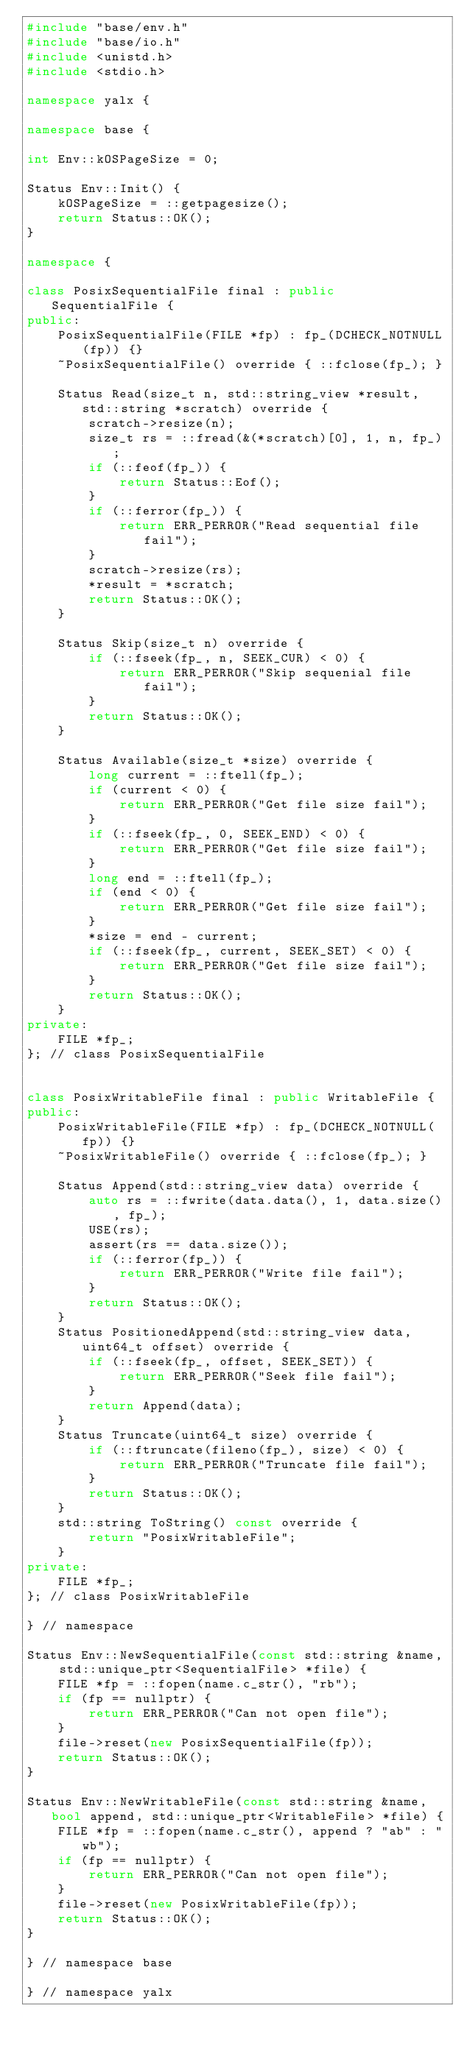Convert code to text. <code><loc_0><loc_0><loc_500><loc_500><_C++_>#include "base/env.h"
#include "base/io.h"
#include <unistd.h>
#include <stdio.h>

namespace yalx {

namespace base {

int Env::kOSPageSize = 0;

Status Env::Init() {
    kOSPageSize = ::getpagesize();
    return Status::OK();
}

namespace {

class PosixSequentialFile final : public SequentialFile {
public:
    PosixSequentialFile(FILE *fp) : fp_(DCHECK_NOTNULL(fp)) {}
    ~PosixSequentialFile() override { ::fclose(fp_); }
    
    Status Read(size_t n, std::string_view *result, std::string *scratch) override {
        scratch->resize(n);
        size_t rs = ::fread(&(*scratch)[0], 1, n, fp_);
        if (::feof(fp_)) {
            return Status::Eof();
        }
        if (::ferror(fp_)) {
            return ERR_PERROR("Read sequential file fail");
        }
        scratch->resize(rs);
        *result = *scratch;
        return Status::OK();
    }

    Status Skip(size_t n) override {
        if (::fseek(fp_, n, SEEK_CUR) < 0) {
            return ERR_PERROR("Skip sequenial file fail");
        }
        return Status::OK();
    }

    Status Available(size_t *size) override {
        long current = ::ftell(fp_);
        if (current < 0) {
            return ERR_PERROR("Get file size fail");
        }
        if (::fseek(fp_, 0, SEEK_END) < 0) {
            return ERR_PERROR("Get file size fail");
        }
        long end = ::ftell(fp_);
        if (end < 0) {
            return ERR_PERROR("Get file size fail");
        }
        *size = end - current;
        if (::fseek(fp_, current, SEEK_SET) < 0) {
            return ERR_PERROR("Get file size fail");
        }
        return Status::OK();
    }
private:
    FILE *fp_;
}; // class PosixSequentialFile


class PosixWritableFile final : public WritableFile {
public:
    PosixWritableFile(FILE *fp) : fp_(DCHECK_NOTNULL(fp)) {}
    ~PosixWritableFile() override { ::fclose(fp_); }
    
    Status Append(std::string_view data) override {
        auto rs = ::fwrite(data.data(), 1, data.size(), fp_);
        USE(rs);
        assert(rs == data.size());
        if (::ferror(fp_)) {
            return ERR_PERROR("Write file fail");
        }
        return Status::OK();
    }
    Status PositionedAppend(std::string_view data, uint64_t offset) override {
        if (::fseek(fp_, offset, SEEK_SET)) {
            return ERR_PERROR("Seek file fail");
        }
        return Append(data);
    }
    Status Truncate(uint64_t size) override {
        if (::ftruncate(fileno(fp_), size) < 0) {
            return ERR_PERROR("Truncate file fail");
        }
        return Status::OK();
    }
    std::string ToString() const override {
        return "PosixWritableFile";
    }
private:
    FILE *fp_;
}; // class PosixWritableFile

} // namespace

Status Env::NewSequentialFile(const std::string &name, std::unique_ptr<SequentialFile> *file) {
    FILE *fp = ::fopen(name.c_str(), "rb");
    if (fp == nullptr) {
        return ERR_PERROR("Can not open file");
    }
    file->reset(new PosixSequentialFile(fp));
    return Status::OK();
}

Status Env::NewWritableFile(const std::string &name, bool append, std::unique_ptr<WritableFile> *file) {
    FILE *fp = ::fopen(name.c_str(), append ? "ab" : "wb");
    if (fp == nullptr) {
        return ERR_PERROR("Can not open file");
    }
    file->reset(new PosixWritableFile(fp));
    return Status::OK();
}

} // namespace base

} // namespace yalx
</code> 